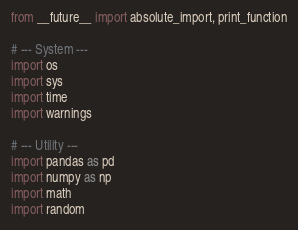Convert code to text. <code><loc_0><loc_0><loc_500><loc_500><_Python_>from __future__ import absolute_import, print_function

# --- System ---
import os
import sys
import time
import warnings

# --- Utility ---
import pandas as pd
import numpy as np
import math
import random</code> 